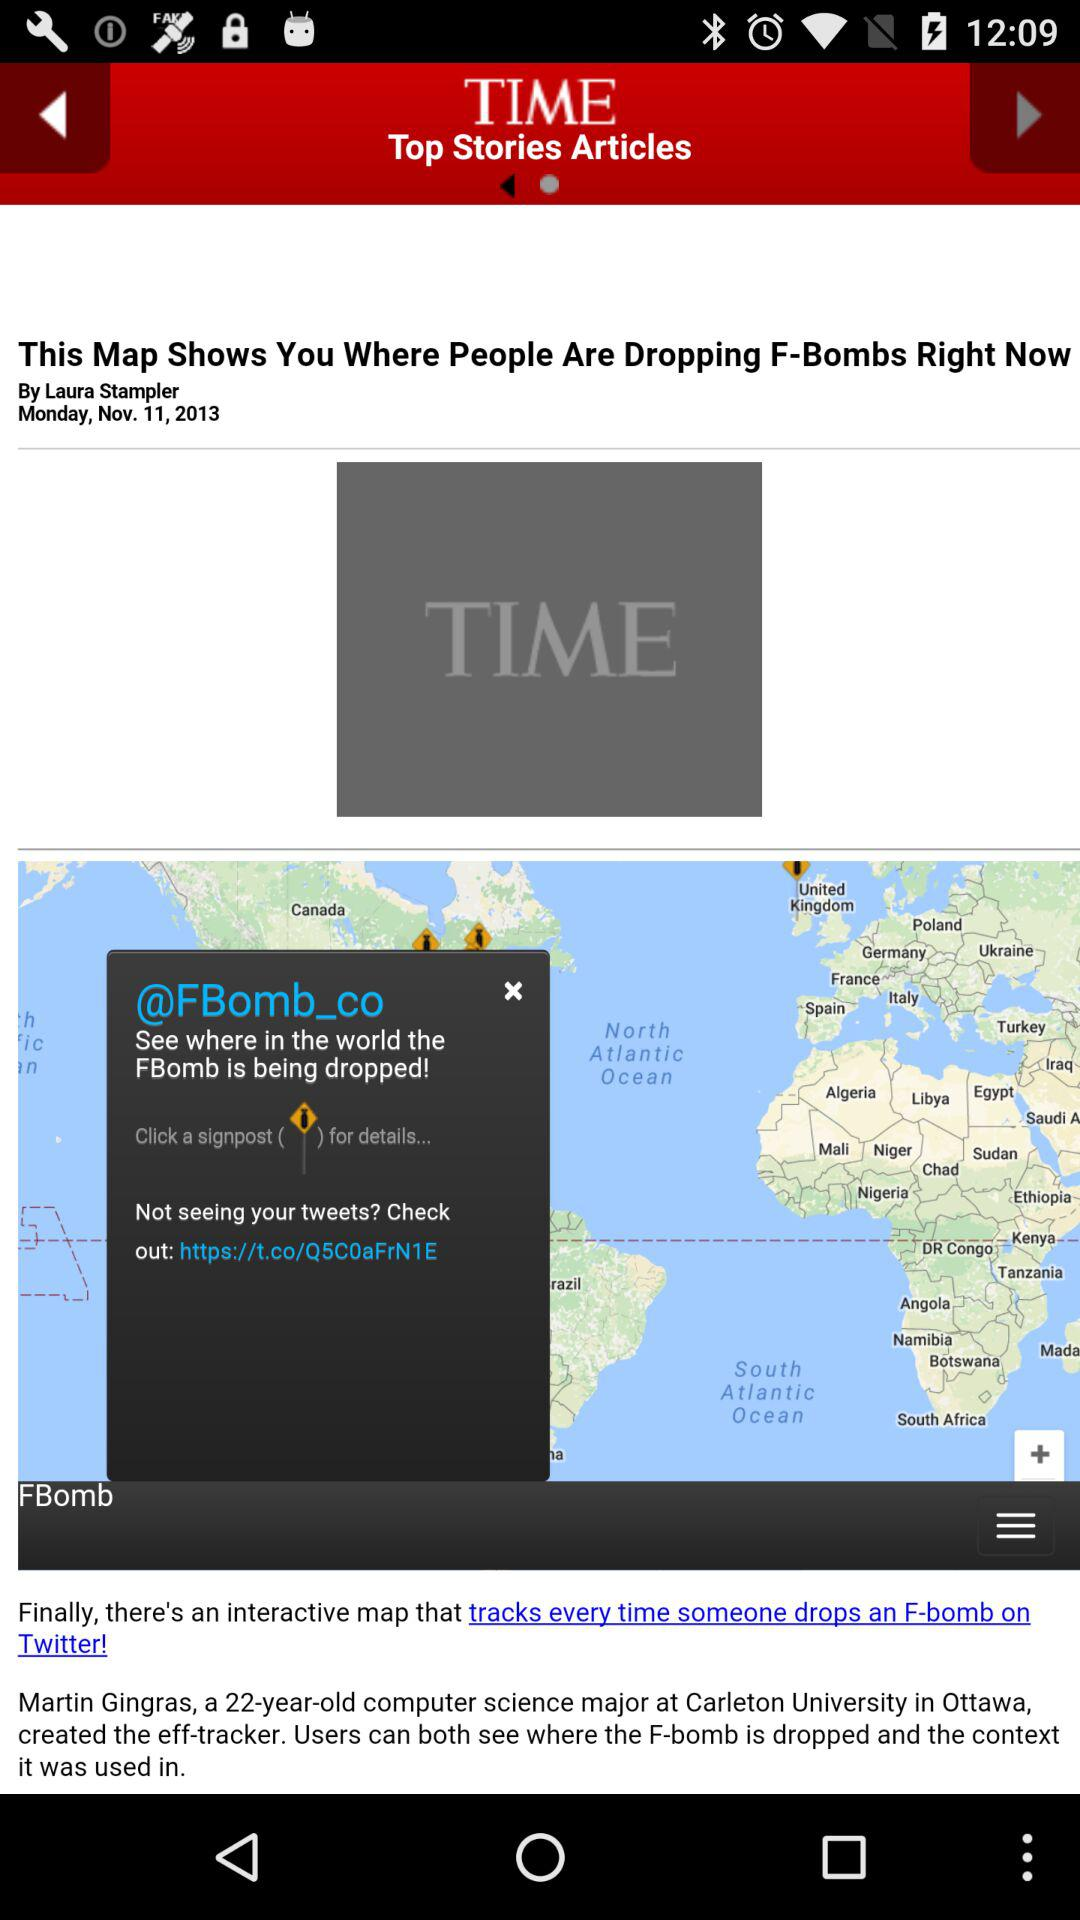What is the publication date? The publication date is Monday, November 11, 2013. 